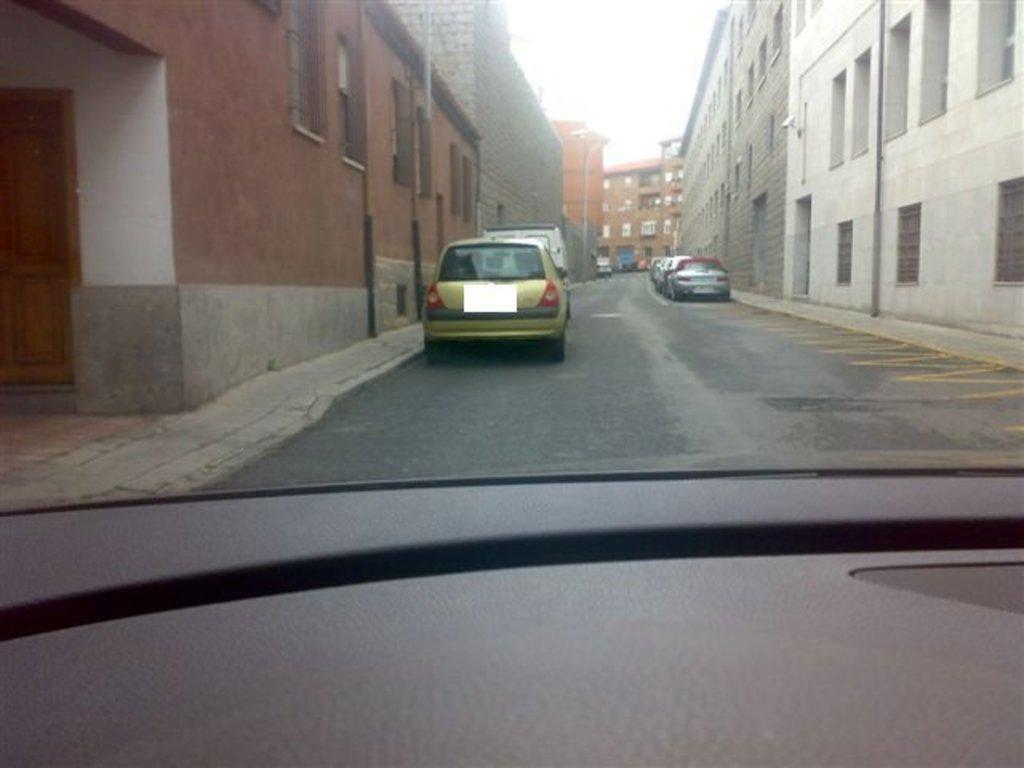In one or two sentences, can you explain what this image depicts? In this picture we can observe some cars parked on either sides of the road. We can observe some buildings in this picture. In the background there is a sky. 